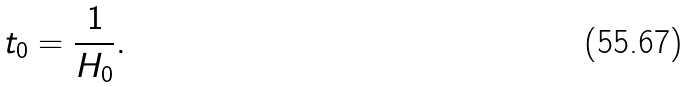<formula> <loc_0><loc_0><loc_500><loc_500>t _ { 0 } = \frac { 1 } { H _ { 0 } } .</formula> 